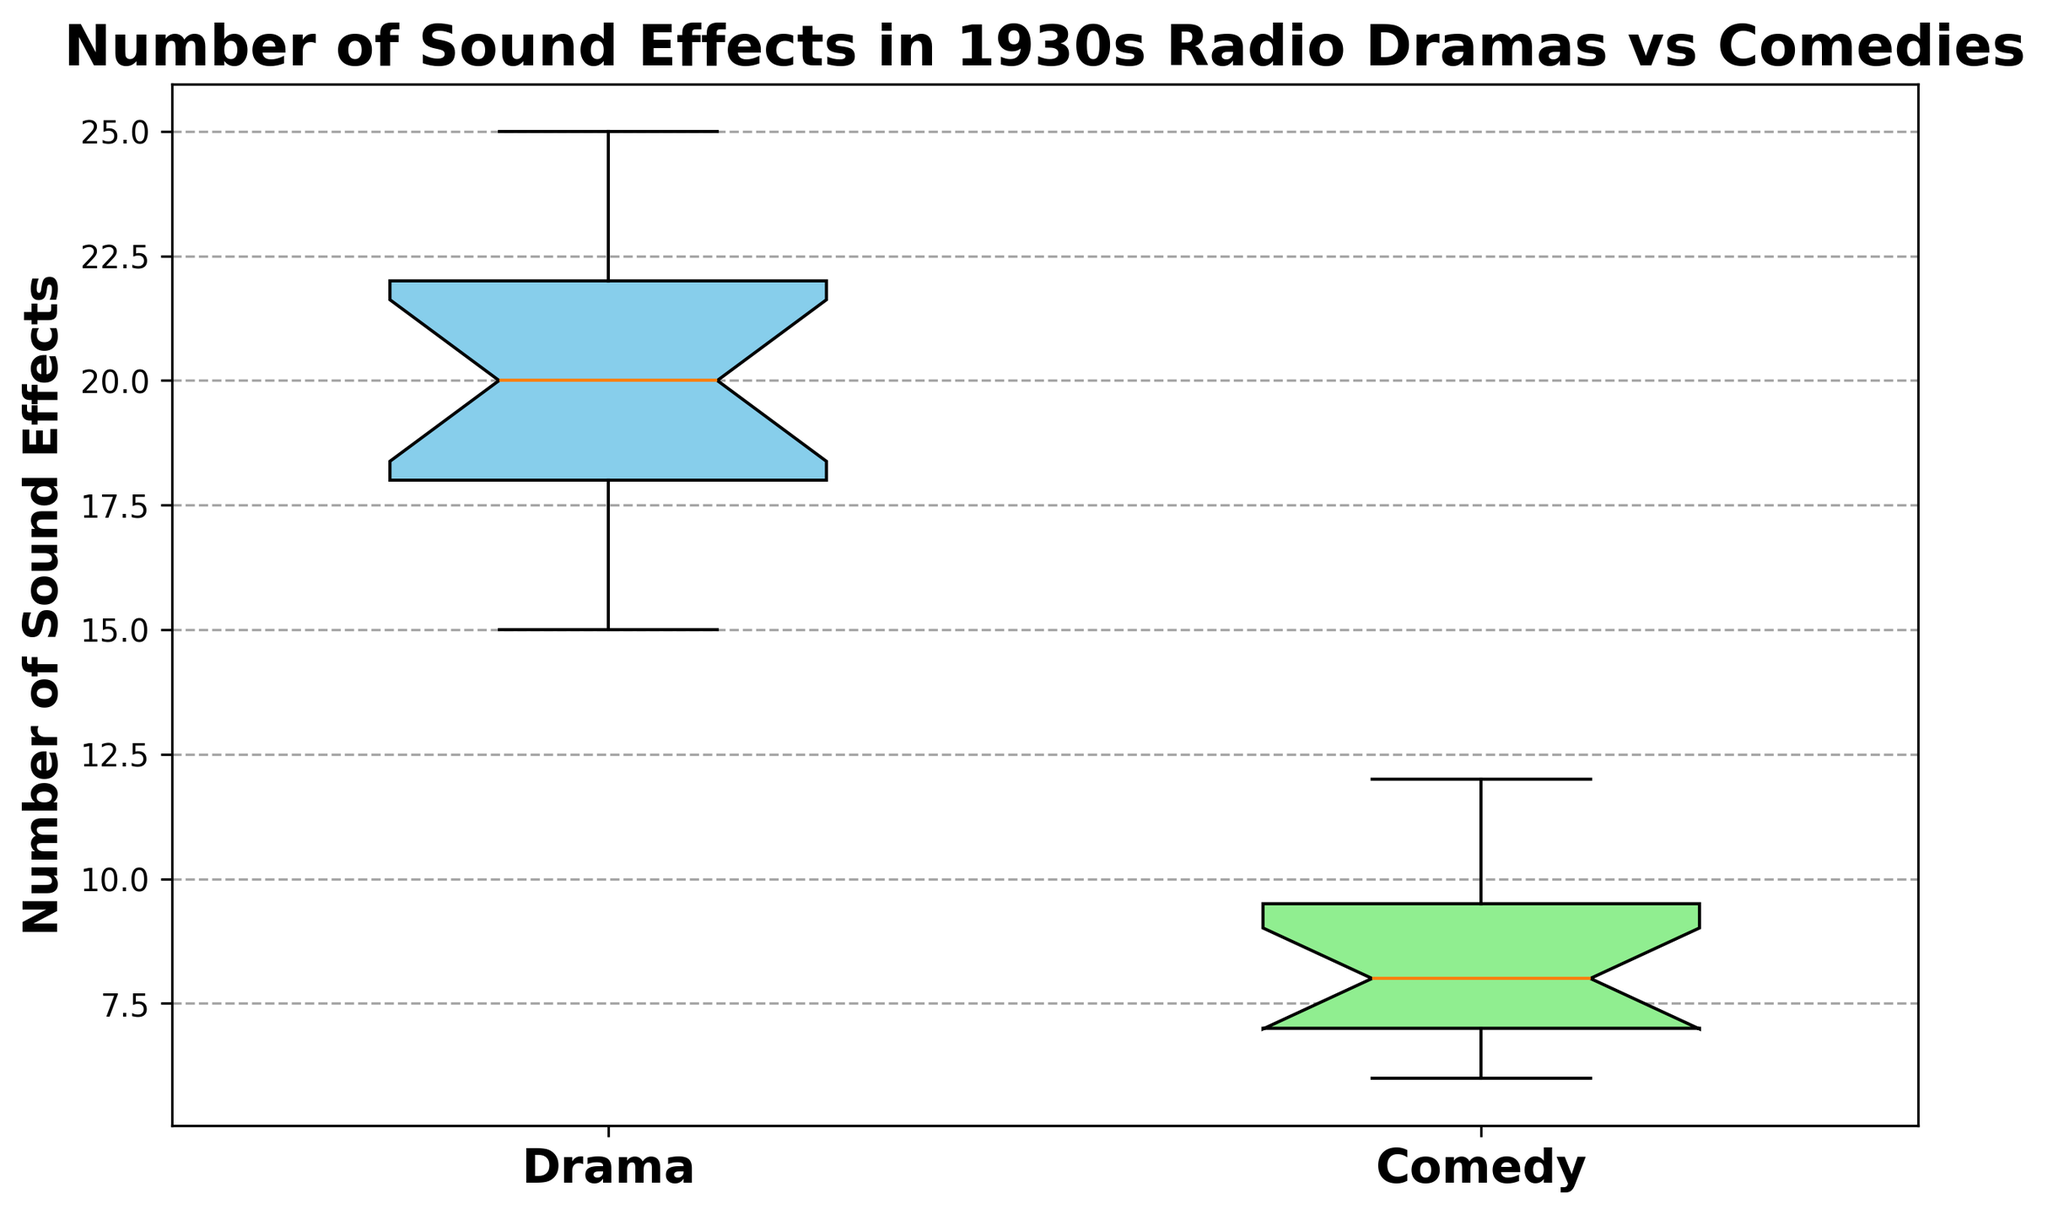What is the median number of sound effects used in dramas? To find the median number of sound effects in dramas, locate the middle value in the sorted list of sound effects counts for the Drama group. Arrange the counts in ascending order: 15, 16, 17, 18, 18, 19, 19, 20, 20, 21, 22, 22, 23, 24, 25. The middle value is the 8th one in this sorted list, which is 20.
Answer: 20 Which genre has the higher median number of sound effects? Compare the median sound effects of both genres. From the box plot, the median for Drama and Comedy can be observed from the central line in each box. The median for Drama is 20, while for Comedy it is about 9. Thus, Drama has the higher median value.
Answer: Drama What is the interquartile range (IQR) for dramas and comedies? The IQR measures the spread of the middle 50% of the data, calculated as the difference between the third quartile (Q3) and the first quartile (Q1). For Drama, Q3 is approximately 23 and Q1 is approximately 18, so IQR = 23 - 18 = 5. For Comedy, Q3 is approximately 10 and Q1 is approximately 7, so IQR = 10 - 7 = 3.
Answer: Drama: 5, Comedy: 3 Which genre has a wider spread of sound effects usage represented by the whiskers of the box plot? The spread can be determined by looking at the length of the whiskers. The whiskers represent the range from the minimum to maximum values, excluding outliers. The whiskers for Drama extend from around 15 to 25, while for Comedy they extend from around 6 to 12. Thus, Drama has a wider spread.
Answer: Drama Are there any outliers in the Comedy data? Outliers are points outside the whisker's range. These are often marked by small circles. In the Comedy box plot, there are no outliers shown outside the whiskers' range, which extends from approximately 6 to 12.
Answer: No What is the difference between the maximum number of sound effects used in dramas and comedies? Identify the maximum sound effects from each genre in the box plots: for Drama, it is 25, and for Comedy, it is 12. The difference is 25 - 12 = 13.
Answer: 13 How does the median number of sound effects in dramas compare with the third quartile (Q3) of comedies? The median for Drama is 20. The third quartile or Q3 for Comedy is approximately 10. 20 is greater than 10, indicating that the median number of sound effects in dramas is higher than the third quartile in comedies.
Answer: Greater than What is the range of the number of sound effects used in comedies? The range is the difference between the maximum and minimum values. In Comedies, the maximum is 12 and the minimum is 6, so the range is 12 - 6 = 6.
Answer: 6 How do the colors of the boxes compare between the two genres? Look at the visual attribute of color in the box plot. The Drama box is colored sky blue, and the Comedy box is colored light green.
Answer: Drama: sky blue, Comedy: light green 